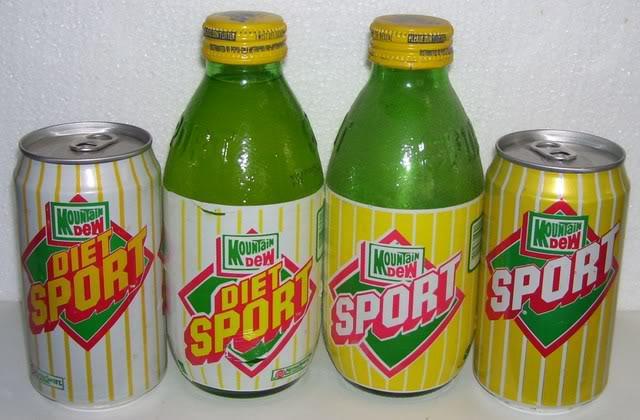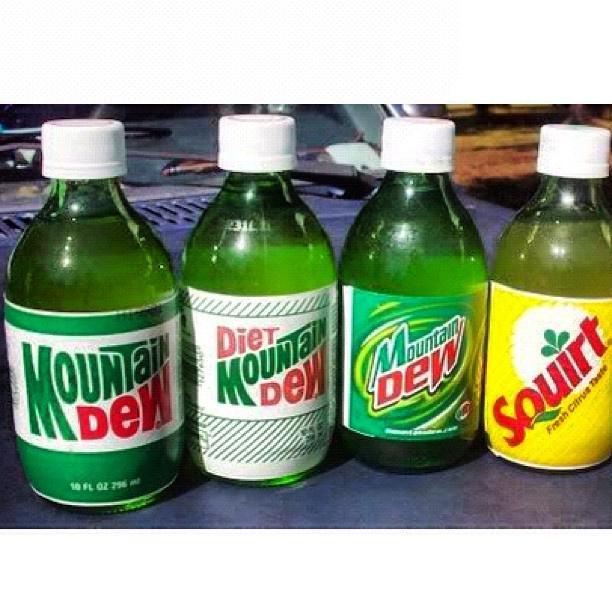The first image is the image on the left, the second image is the image on the right. Analyze the images presented: Is the assertion "All of the bottles have caps." valid? Answer yes or no. Yes. The first image is the image on the left, the second image is the image on the right. Assess this claim about the two images: "The right image contains at least twice as many soda bottles as the left image.". Correct or not? Answer yes or no. Yes. 